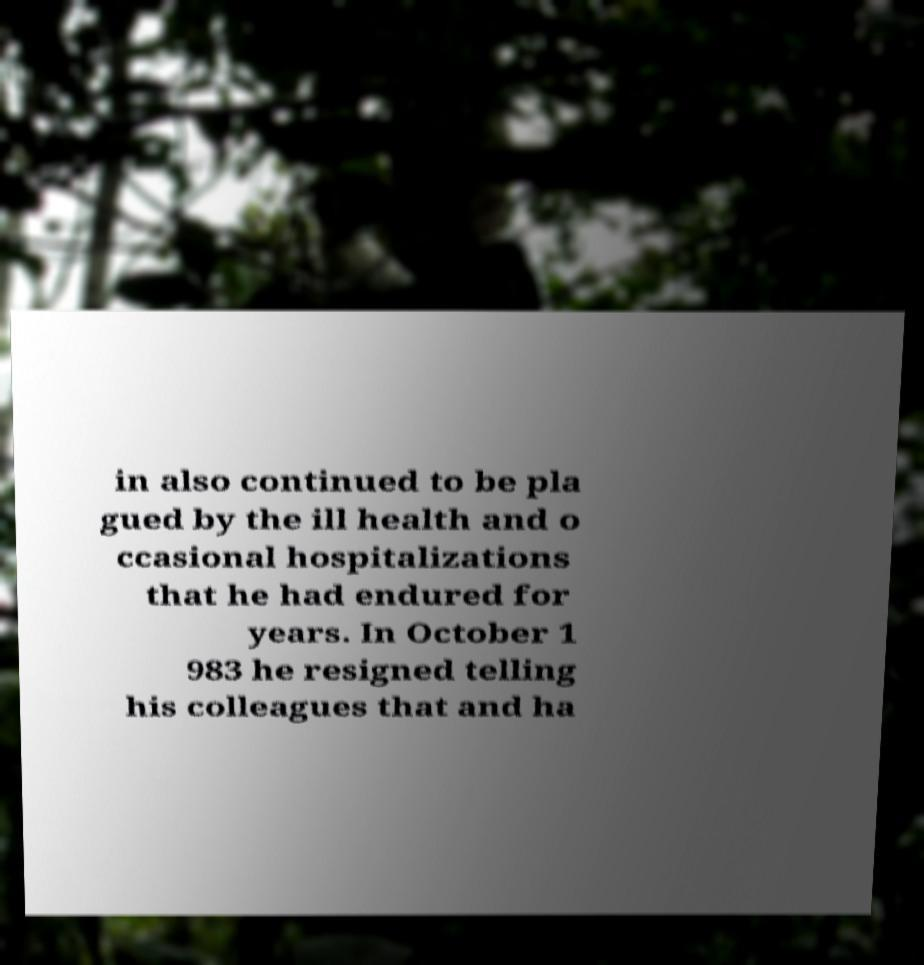Can you read and provide the text displayed in the image?This photo seems to have some interesting text. Can you extract and type it out for me? in also continued to be pla gued by the ill health and o ccasional hospitalizations that he had endured for years. In October 1 983 he resigned telling his colleagues that and ha 